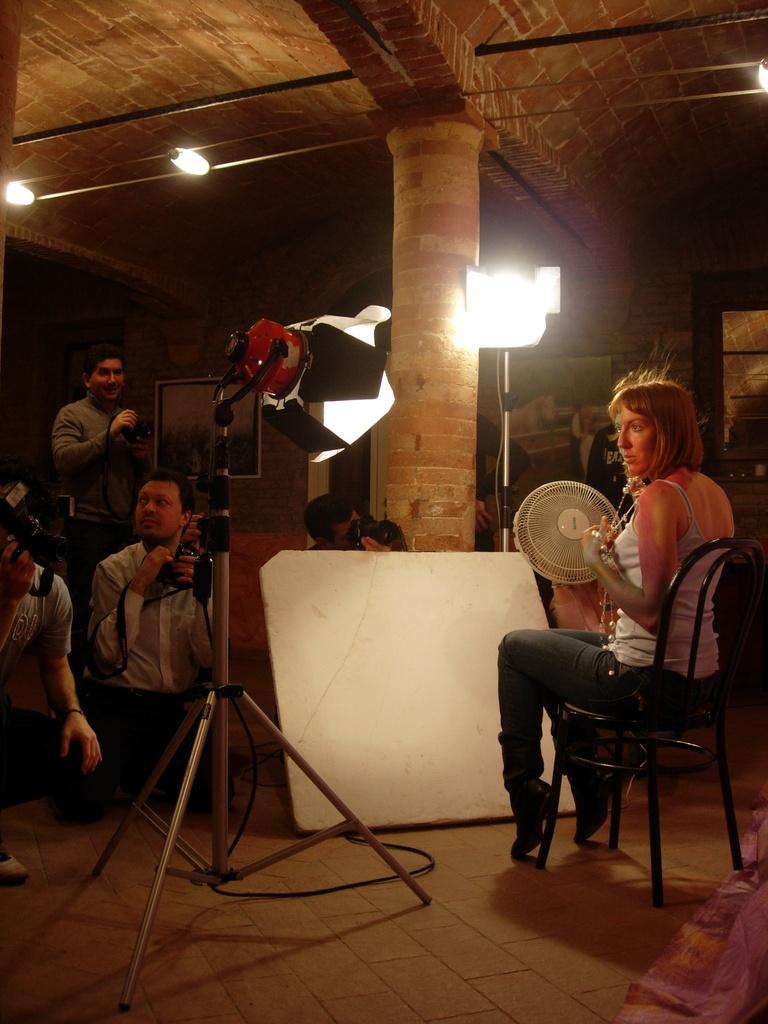What is the woman in the image doing? The woman is sitting on a chair in the image. Where is the woman located in the image? The woman is on the right side of the image. How many people are present in the image? There are four people in the image. What are the four people doing? The four people are capturing an image of the woman. What can be seen in the background of the image? There are lights visible in the image. What type of silver is the woman wearing in the image? There is no silver visible on the woman in the image. What is the value of the vest worn by the woman in the image? There is no vest worn by the woman in the image. 